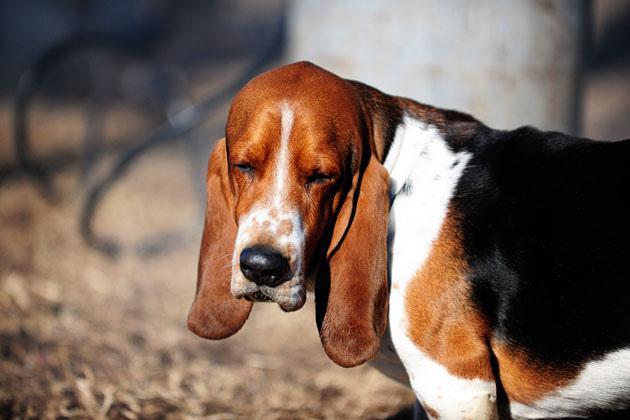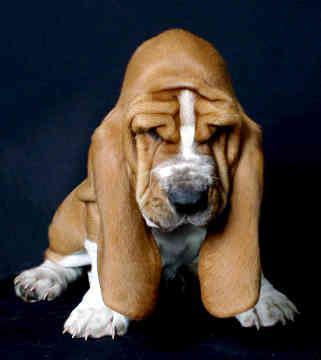The first image is the image on the left, the second image is the image on the right. Evaluate the accuracy of this statement regarding the images: "A basset hound is sleeping on a platform facing the right, with one ear hanging down.". Is it true? Answer yes or no. No. 